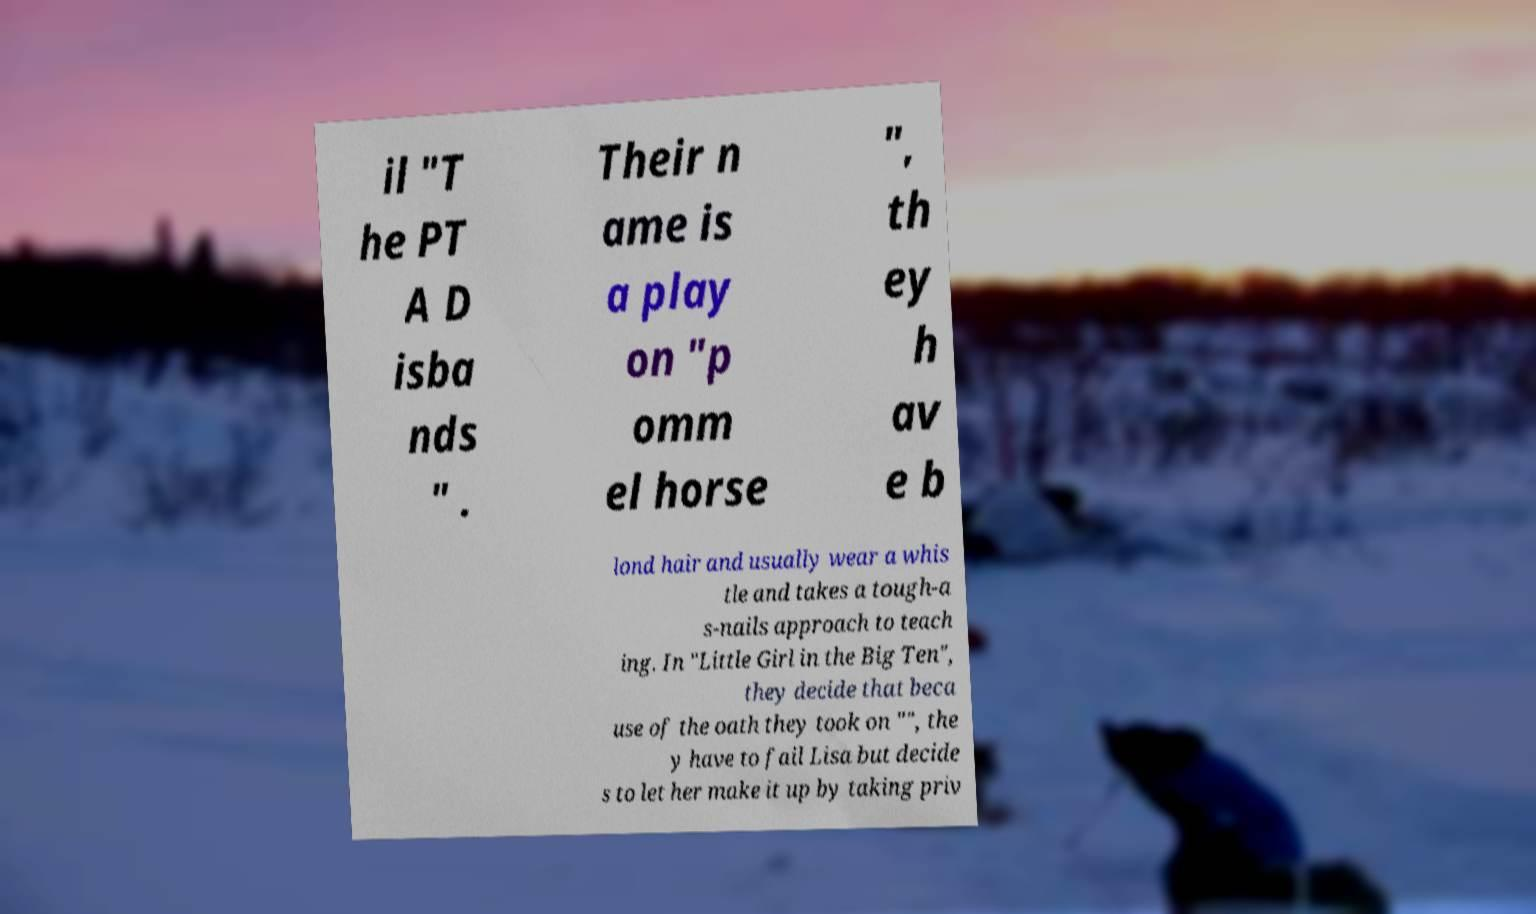What messages or text are displayed in this image? I need them in a readable, typed format. il "T he PT A D isba nds " . Their n ame is a play on "p omm el horse ", th ey h av e b lond hair and usually wear a whis tle and takes a tough-a s-nails approach to teach ing. In "Little Girl in the Big Ten", they decide that beca use of the oath they took on "", the y have to fail Lisa but decide s to let her make it up by taking priv 